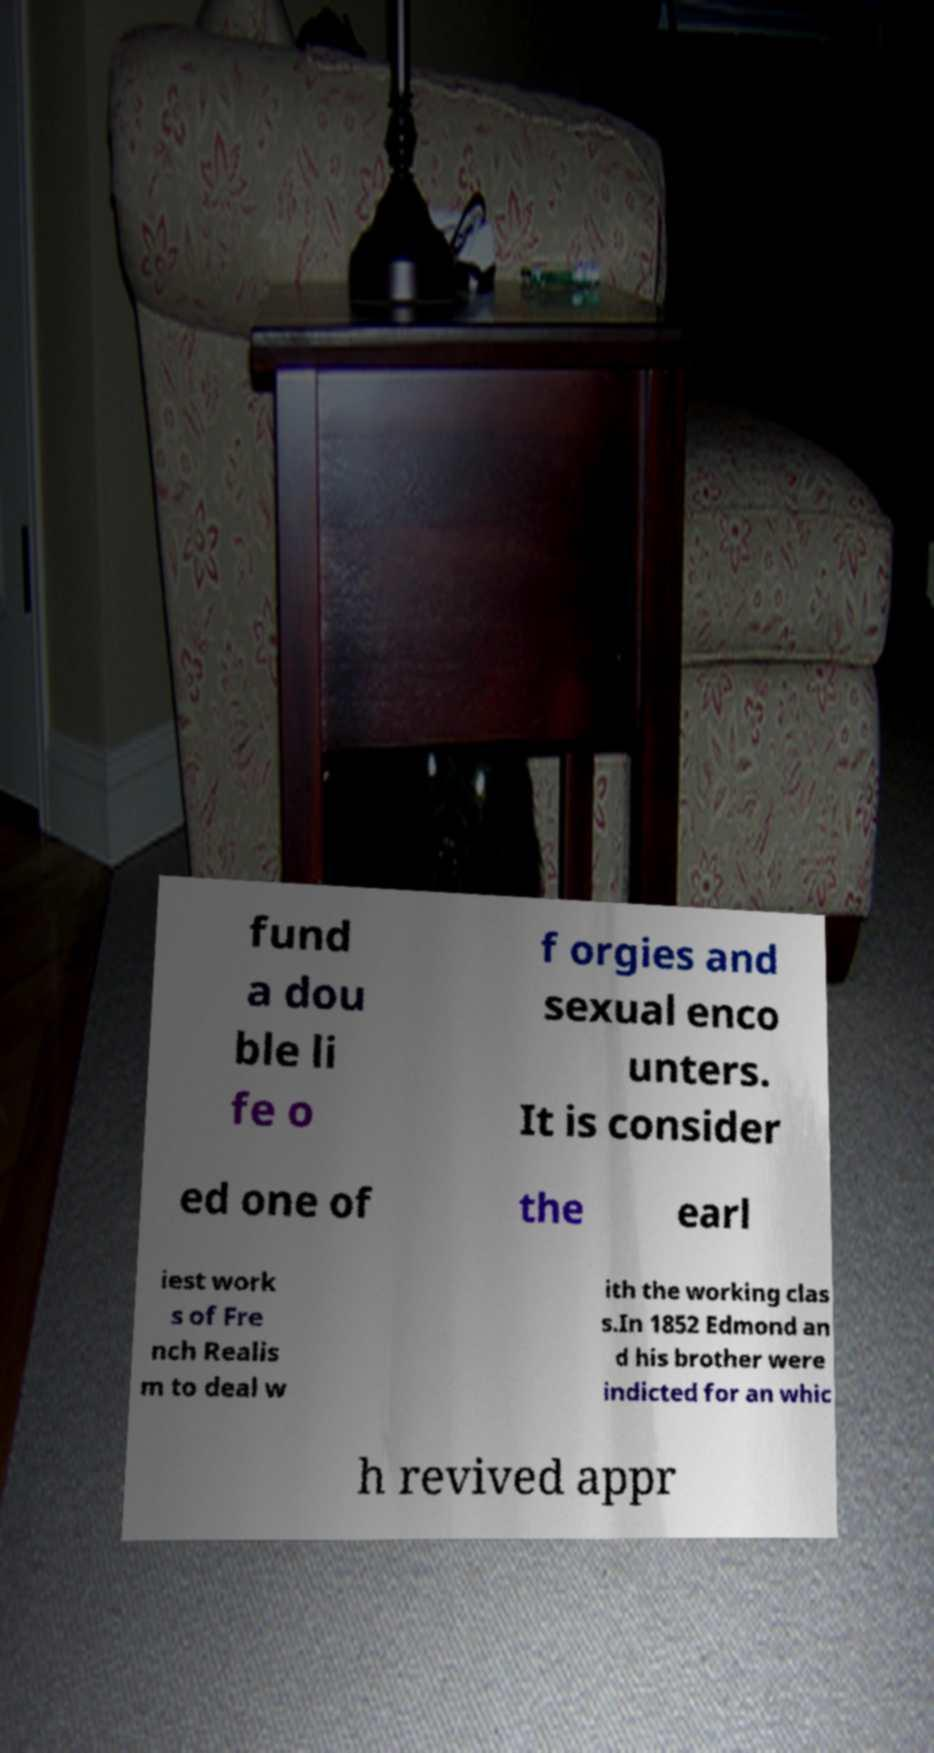Can you read and provide the text displayed in the image?This photo seems to have some interesting text. Can you extract and type it out for me? fund a dou ble li fe o f orgies and sexual enco unters. It is consider ed one of the earl iest work s of Fre nch Realis m to deal w ith the working clas s.In 1852 Edmond an d his brother were indicted for an whic h revived appr 